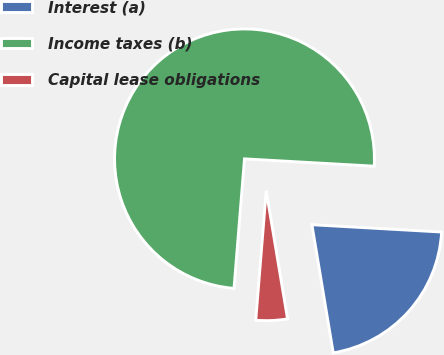<chart> <loc_0><loc_0><loc_500><loc_500><pie_chart><fcel>Interest (a)<fcel>Income taxes (b)<fcel>Capital lease obligations<nl><fcel>21.48%<fcel>74.62%<fcel>3.91%<nl></chart> 